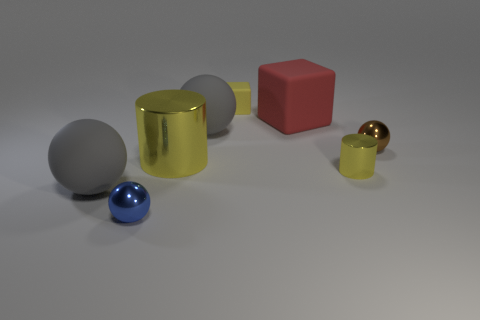Do the large metallic object and the tiny yellow shiny object have the same shape?
Keep it short and to the point. Yes. The small brown object behind the blue thing has what shape?
Keep it short and to the point. Sphere. There is a blue thing; does it have the same size as the yellow metallic cylinder that is to the right of the big red matte object?
Your answer should be very brief. Yes. Are there any tiny brown objects that have the same material as the big yellow thing?
Offer a terse response. Yes. How many balls are metal things or large red things?
Make the answer very short. 2. There is a large gray matte object that is in front of the big cylinder; are there any gray balls behind it?
Ensure brevity in your answer.  Yes. Are there fewer tiny yellow metallic things than large red matte spheres?
Keep it short and to the point. No. What number of small blue metallic things are the same shape as the red object?
Your answer should be compact. 0. How many blue objects are metallic cylinders or small matte cubes?
Your answer should be compact. 0. There is a gray thing on the right side of the metal sphere in front of the big yellow thing; what size is it?
Provide a succinct answer. Large. 